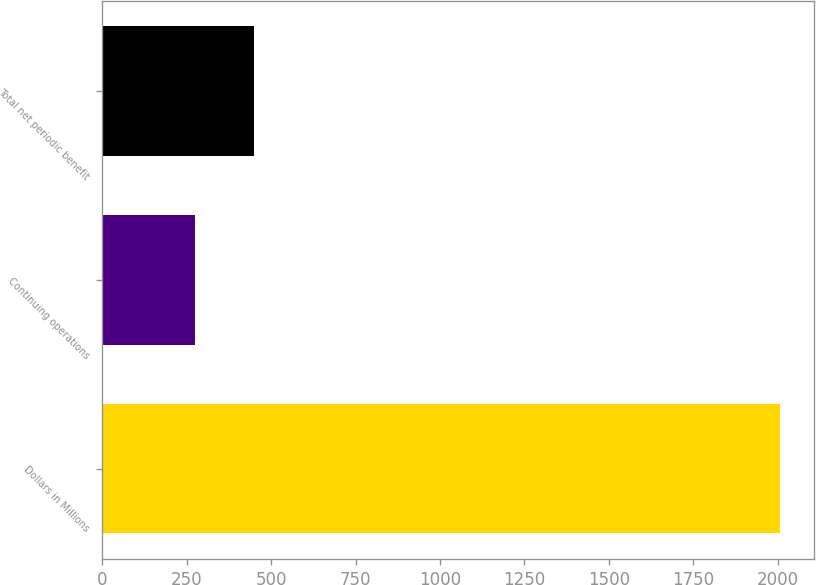Convert chart. <chart><loc_0><loc_0><loc_500><loc_500><bar_chart><fcel>Dollars in Millions<fcel>Continuing operations<fcel>Total net periodic benefit<nl><fcel>2008<fcel>275<fcel>448.3<nl></chart> 